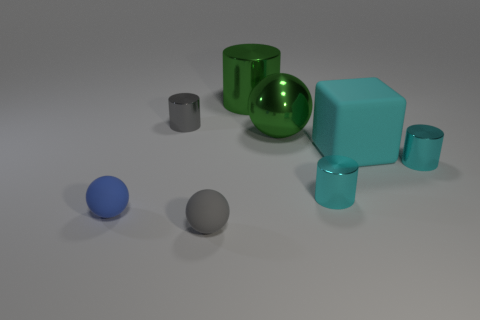Subtract all matte spheres. How many spheres are left? 1 Subtract all brown blocks. How many cyan cylinders are left? 2 Add 1 large green metal cylinders. How many objects exist? 9 Subtract all blue balls. How many balls are left? 2 Subtract all blocks. How many objects are left? 7 Subtract 1 spheres. How many spheres are left? 2 Subtract 0 purple cylinders. How many objects are left? 8 Subtract all green spheres. Subtract all green cylinders. How many spheres are left? 2 Subtract all small cyan shiny objects. Subtract all gray matte balls. How many objects are left? 5 Add 8 green cylinders. How many green cylinders are left? 9 